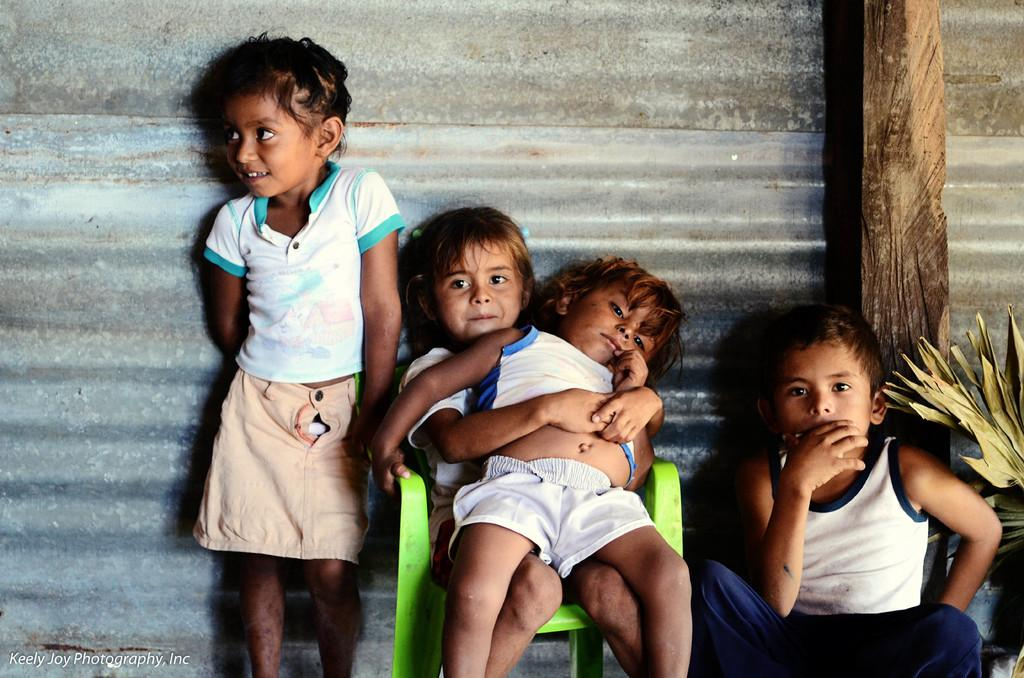How many kids are present in the image? There are four kids in the image. What are two of the kids doing in the image? Two of the kids are sitting on chairs. What can be seen in the background of the image? There is a metal sheet visible in the background of the image. What type of oven can be seen in the image? There is no oven present in the image. Can you tell me how many items are being sold at the market in the image? There is no market present in the image. 